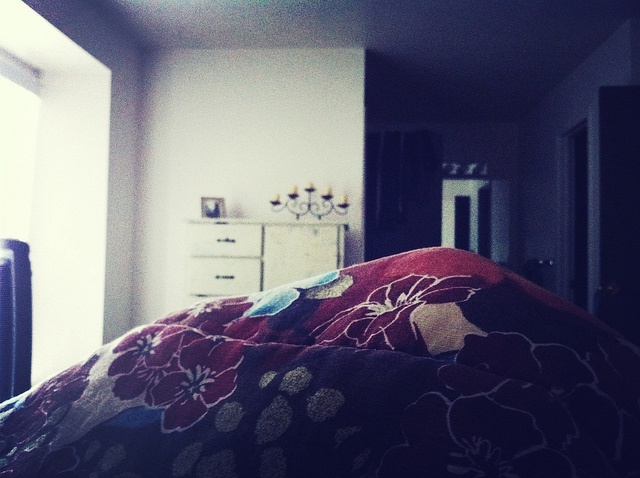Describe the objects in this image and their specific colors. I can see a bed in beige, navy, and purple tones in this image. 